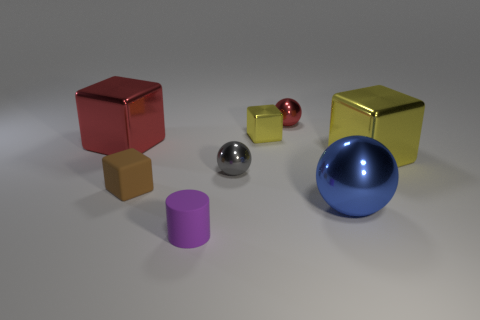Are there any other things that have the same shape as the purple thing?
Your answer should be compact. No. There is a red metal thing to the left of the purple matte cylinder that is in front of the large yellow thing; what number of tiny things are in front of it?
Your answer should be very brief. 3. Are there any other things that are the same color as the big shiny ball?
Ensure brevity in your answer.  No. There is a sphere in front of the gray thing; is its size the same as the small brown cube?
Your response must be concise. No. There is a large cube to the right of the gray shiny thing; how many metallic objects are behind it?
Your response must be concise. 3. Is there a big shiny block that is on the right side of the small metallic sphere that is behind the big thing that is behind the big yellow metallic cube?
Your answer should be very brief. Yes. There is a big blue object that is the same shape as the gray shiny thing; what material is it?
Your response must be concise. Metal. Are there any other things that have the same material as the small brown object?
Make the answer very short. Yes. Does the large blue object have the same material as the ball left of the tiny red metallic ball?
Your answer should be very brief. Yes. There is a red object to the left of the small rubber cylinder that is in front of the big blue metallic ball; what is its shape?
Provide a short and direct response. Cube. 